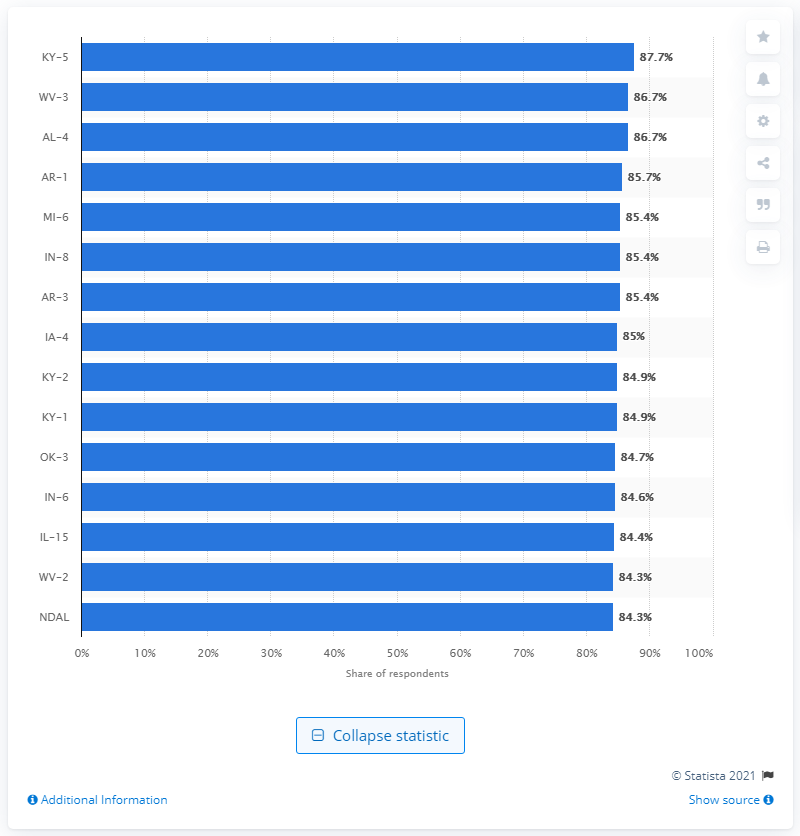Give some essential details in this illustration. According to the survey results in Kentucky's 5th congressional district, 87.7% of respondents reported using Facebook at least once a week. 